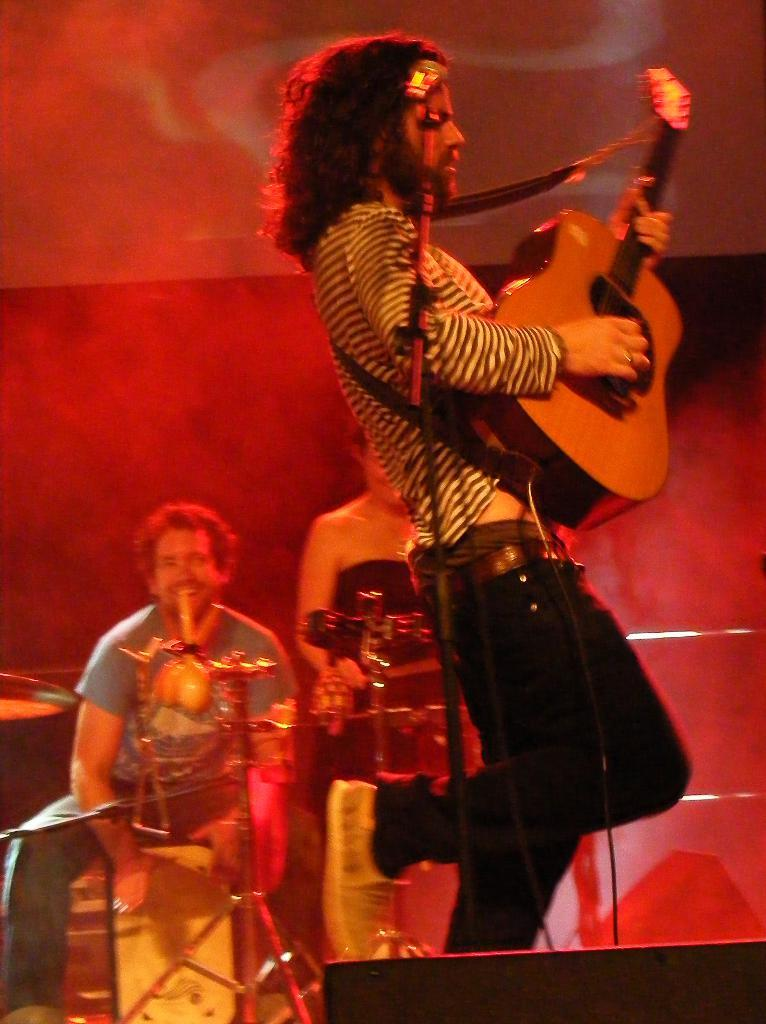What is the man in the image doing? The man is playing a guitar in the image. Can you describe the activity of the man in the image? The man is standing and playing a guitar. Are there any other people visible in the image? Yes, there are two persons standing in the background of the image. What type of dirt can be seen on the man's feet in the image? There is no dirt visible on the man's feet in the image, and the man's feet are not even shown in the image. 